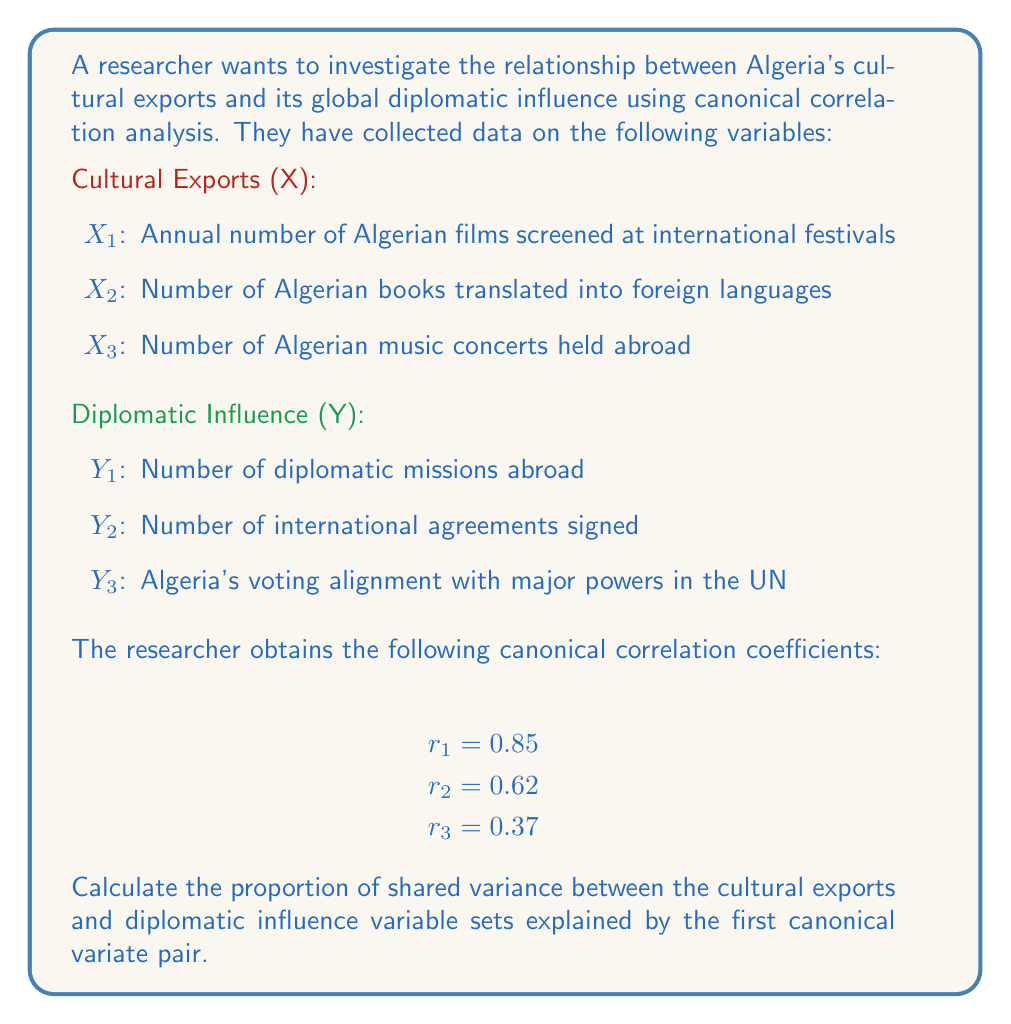Teach me how to tackle this problem. To solve this problem, we need to understand the concept of shared variance in canonical correlation analysis and how to calculate it using the canonical correlation coefficients.

1) In canonical correlation analysis, the squared canonical correlation coefficient ($r^2$) represents the amount of variance shared between the canonical variates.

2) The proportion of shared variance explained by each canonical variate pair is calculated as:

   $$\frac{r_i^2}{\sum_{j=1}^p r_j^2}$$

   where $r_i$ is the canonical correlation coefficient for the i-th pair, and p is the number of canonical correlations.

3) In this case, we're interested in the first canonical variate pair, so we'll use $r_1 = 0.85$.

4) First, let's calculate the squared canonical correlations:

   $r_1^2 = 0.85^2 = 0.7225$
   $r_2^2 = 0.62^2 = 0.3844$
   $r_3^2 = 0.37^2 = 0.1369$

5) Now, we sum all the squared canonical correlations:

   $\sum_{j=1}^3 r_j^2 = 0.7225 + 0.3844 + 0.1369 = 1.2438$

6) Finally, we can calculate the proportion of shared variance explained by the first canonical variate pair:

   $$\frac{r_1^2}{\sum_{j=1}^3 r_j^2} = \frac{0.7225}{1.2438} \approx 0.5808$$

7) To express this as a percentage, we multiply by 100:

   $0.5808 * 100 \approx 58.08\%$

Thus, the first canonical variate pair explains approximately 58.08% of the shared variance between Algeria's cultural exports and its global diplomatic influence.
Answer: The proportion of shared variance between Algeria's cultural exports and diplomatic influence variable sets explained by the first canonical variate pair is approximately 0.5808 or 58.08%. 